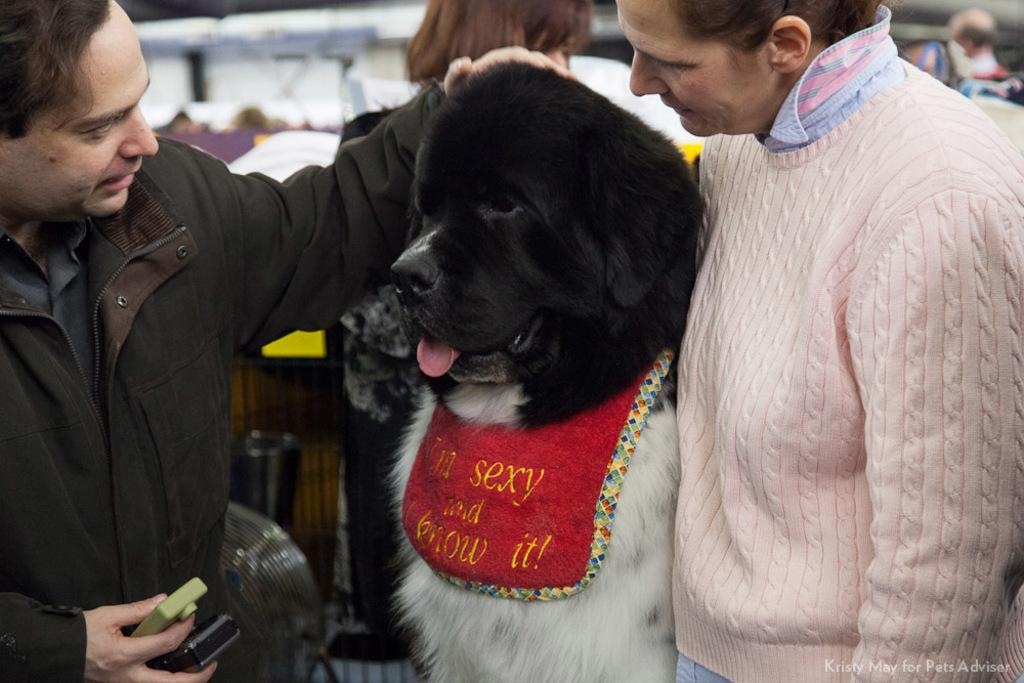Who or what can be seen in the image? There are people and a black dog in the image. Can you describe the dog in the image? The dog in the image is black. What type of bread is being used to create a rhythm in the image? There is no bread or rhythm present in the image; it features people and a black dog. 